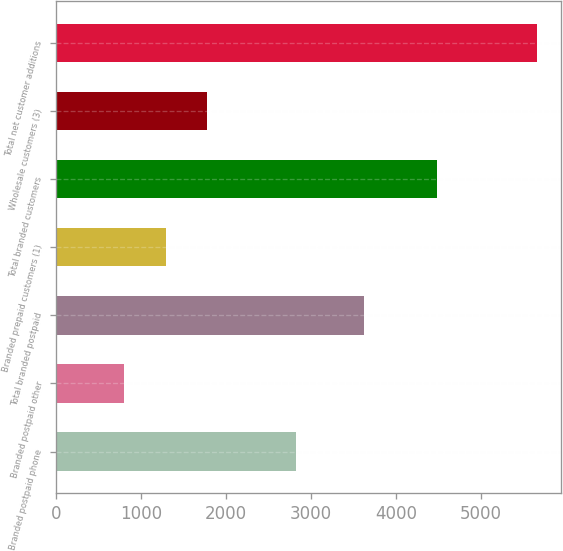Convert chart. <chart><loc_0><loc_0><loc_500><loc_500><bar_chart><fcel>Branded postpaid phone<fcel>Branded postpaid other<fcel>Total branded postpaid<fcel>Branded prepaid customers (1)<fcel>Total branded customers<fcel>Wholesale customers (3)<fcel>Total net customer additions<nl><fcel>2817<fcel>803<fcel>3620<fcel>1288.5<fcel>4475<fcel>1774<fcel>5658<nl></chart> 